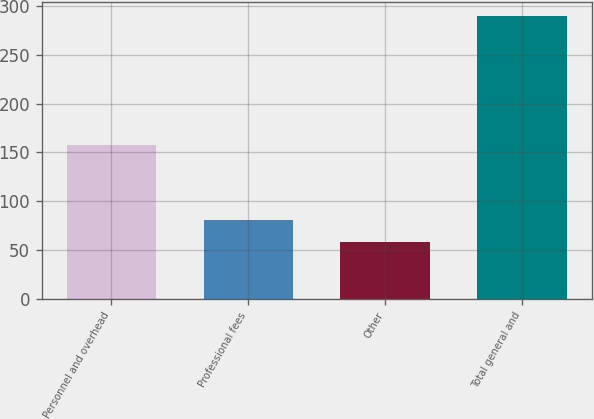<chart> <loc_0><loc_0><loc_500><loc_500><bar_chart><fcel>Personnel and overhead<fcel>Professional fees<fcel>Other<fcel>Total general and<nl><fcel>158<fcel>81.2<fcel>58<fcel>290<nl></chart> 